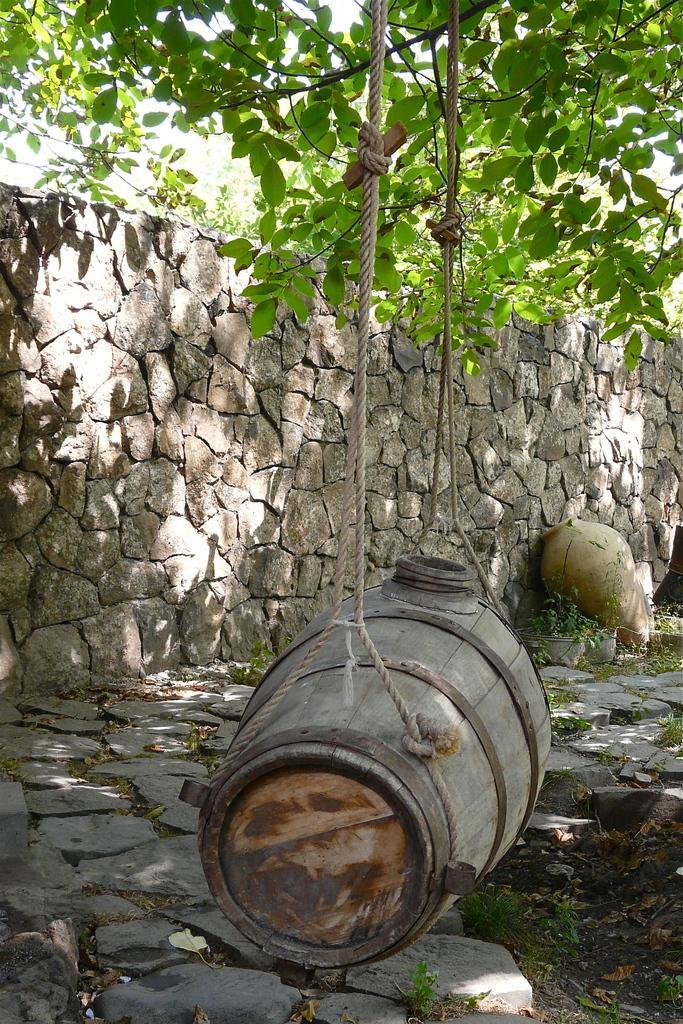Describe this image in one or two sentences. In this image, I can see a wooden barrel, which is hanging with the ropes. On the right side of the image, I can see a flower vase. In the background, there are trees and a wall. At the bottom of the image, I can see the rocks. 